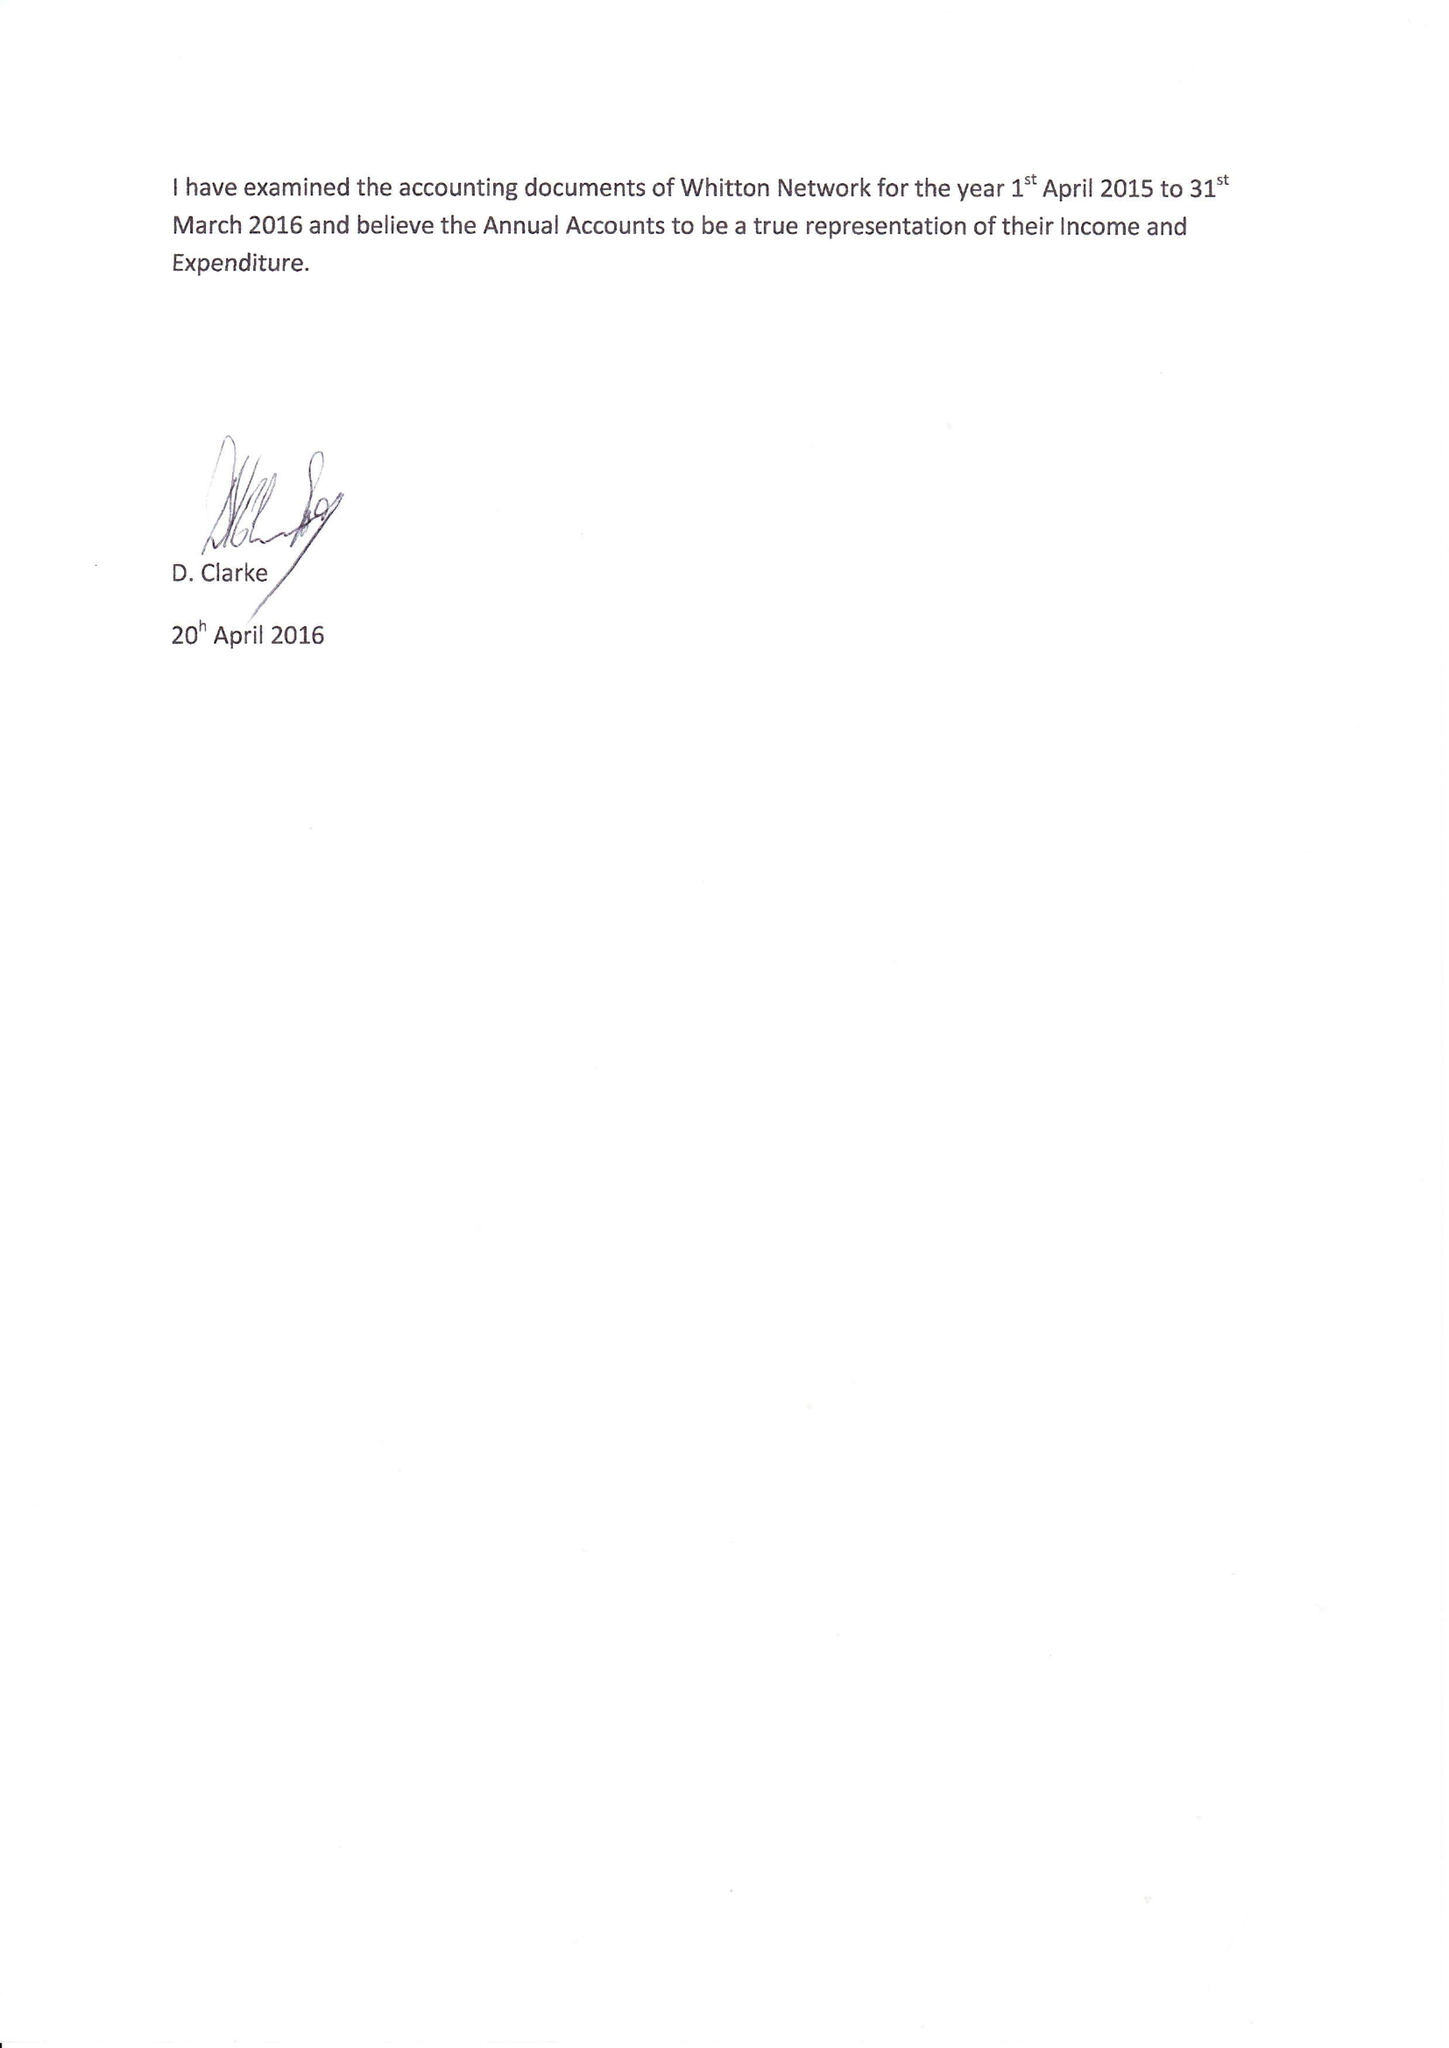What is the value for the address__postcode?
Answer the question using a single word or phrase. TW2 7AP 